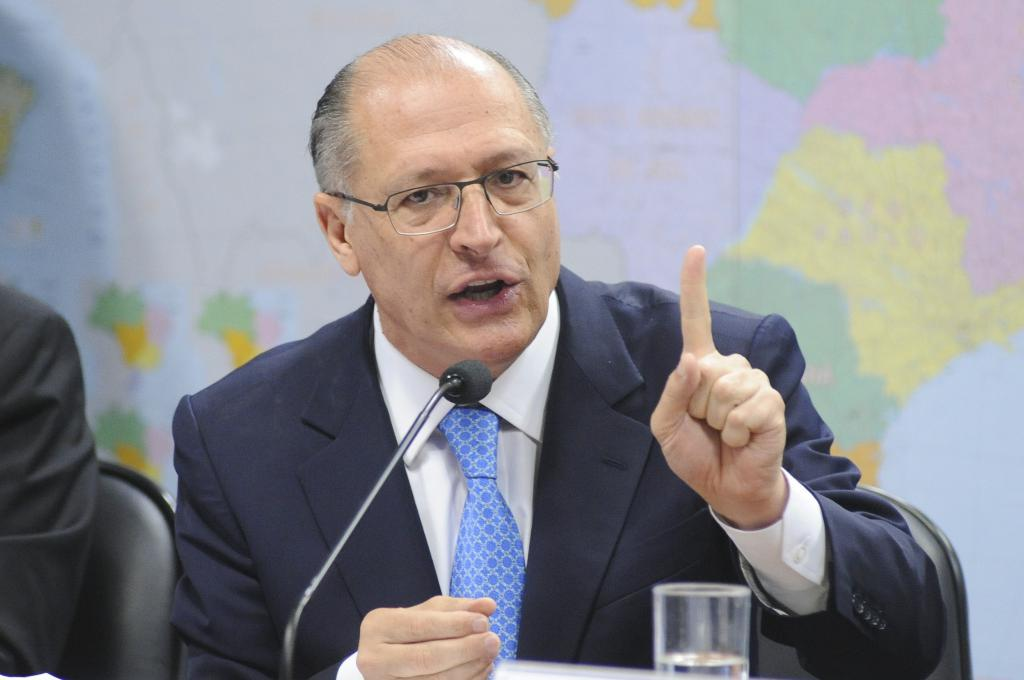What is the main subject of the image? There is a man sitting in the center of the image. What is the man wearing? The man is wearing a suit. What objects can be seen at the bottom of the image? There is a microphone and a glass at the bottom of the image. What can be seen on the wall in the background of the image? There is a map pasted on the wall in the background of the image. What type of truck is parked behind the man in the image? There is no truck visible in the image; it only features a man sitting, a microphone, a glass, and a map on the wall. What is the governor's opinion on the map in the image? There is no indication of a governor or their opinion in the image; it only shows a man, a microphone, a glass, and a map on the wall. 